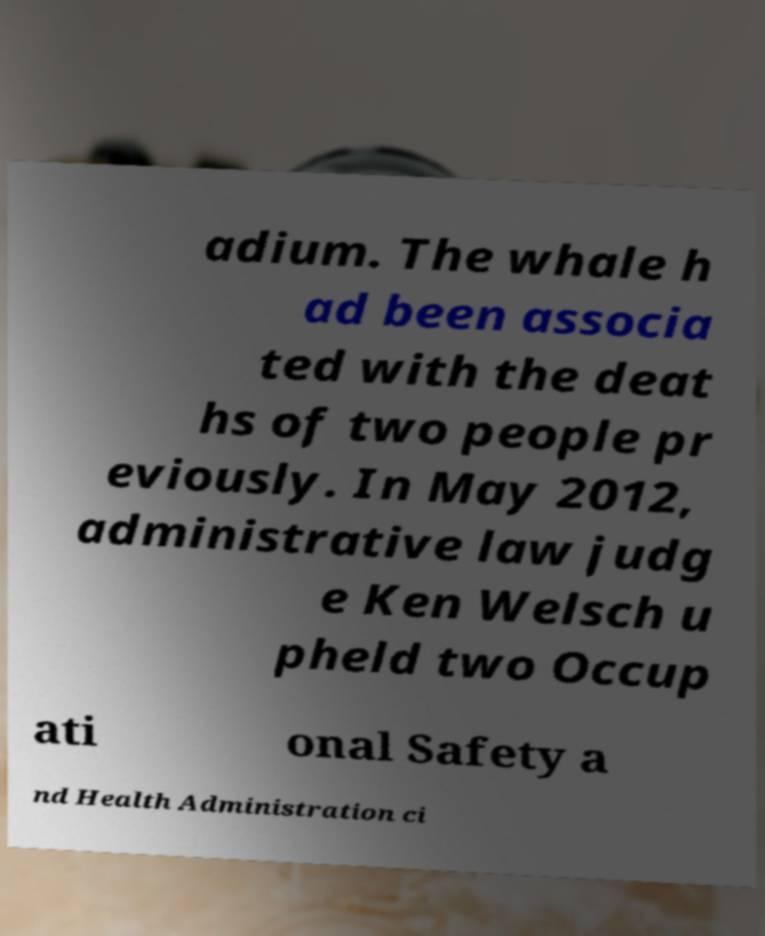Can you read and provide the text displayed in the image?This photo seems to have some interesting text. Can you extract and type it out for me? adium. The whale h ad been associa ted with the deat hs of two people pr eviously. In May 2012, administrative law judg e Ken Welsch u pheld two Occup ati onal Safety a nd Health Administration ci 